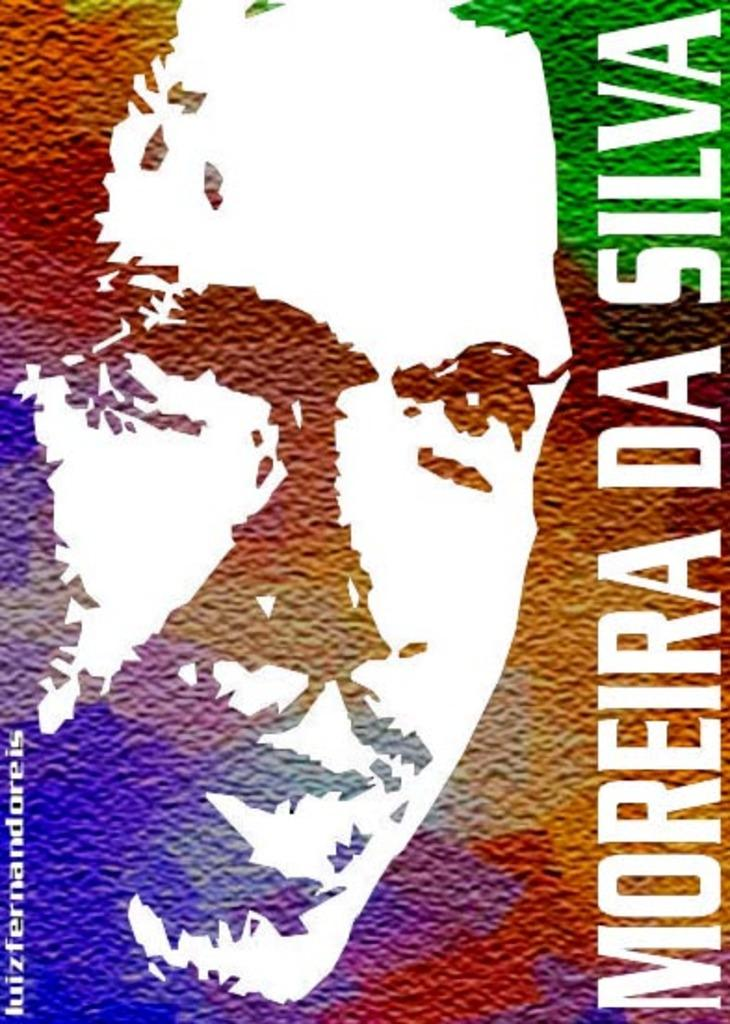<image>
Describe the image concisely. A poster shows a mans face and then name Moreira Da Silva. 